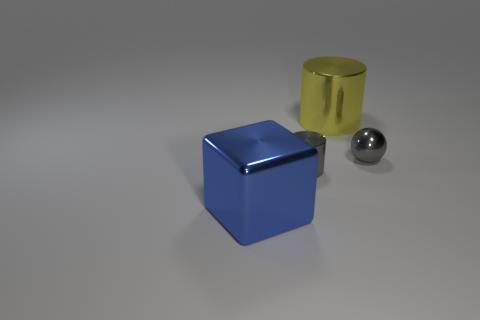Add 3 red cylinders. How many objects exist? 7 Subtract all balls. How many objects are left? 3 Add 2 small purple cubes. How many small purple cubes exist? 2 Subtract 0 green cubes. How many objects are left? 4 Subtract all large red spheres. Subtract all shiny things. How many objects are left? 0 Add 1 small gray objects. How many small gray objects are left? 3 